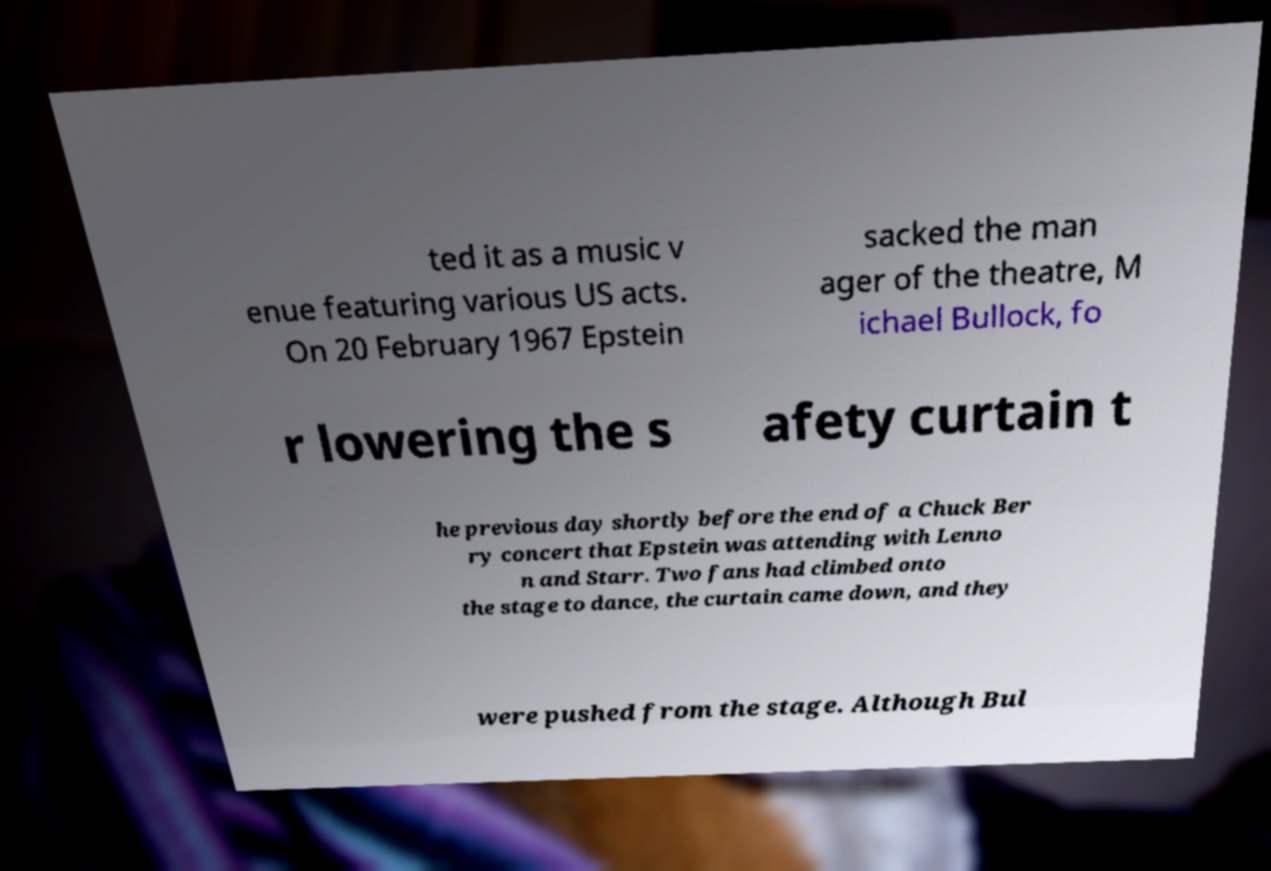Please read and relay the text visible in this image. What does it say? ted it as a music v enue featuring various US acts. On 20 February 1967 Epstein sacked the man ager of the theatre, M ichael Bullock, fo r lowering the s afety curtain t he previous day shortly before the end of a Chuck Ber ry concert that Epstein was attending with Lenno n and Starr. Two fans had climbed onto the stage to dance, the curtain came down, and they were pushed from the stage. Although Bul 